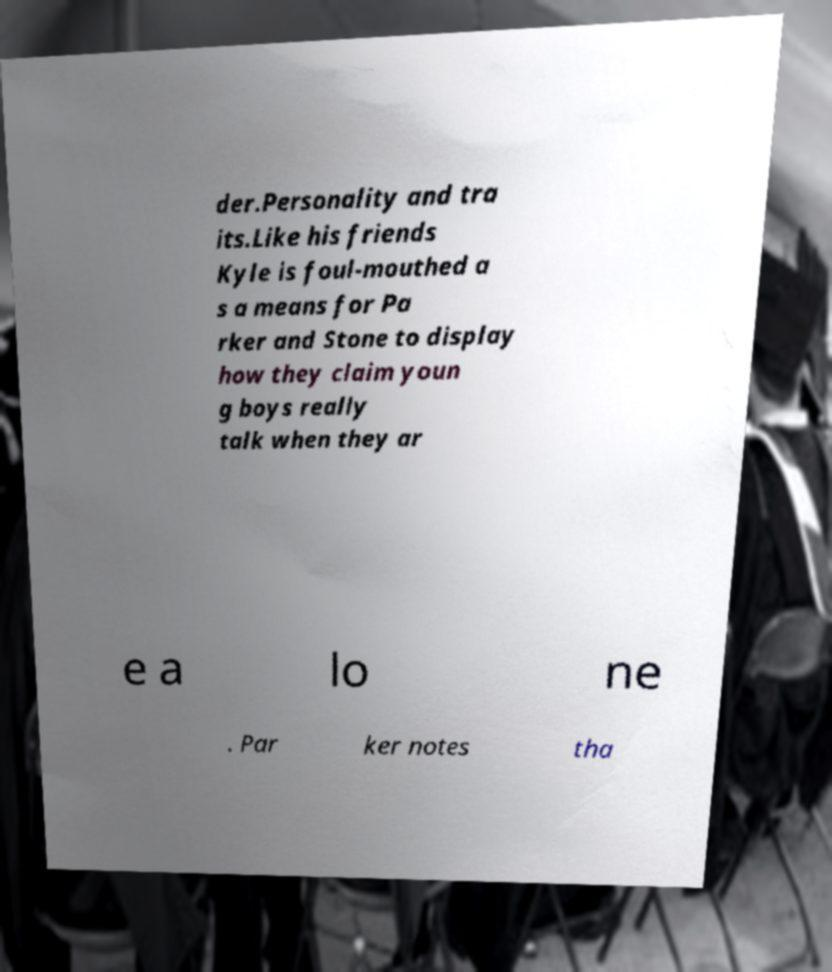What messages or text are displayed in this image? I need them in a readable, typed format. der.Personality and tra its.Like his friends Kyle is foul-mouthed a s a means for Pa rker and Stone to display how they claim youn g boys really talk when they ar e a lo ne . Par ker notes tha 